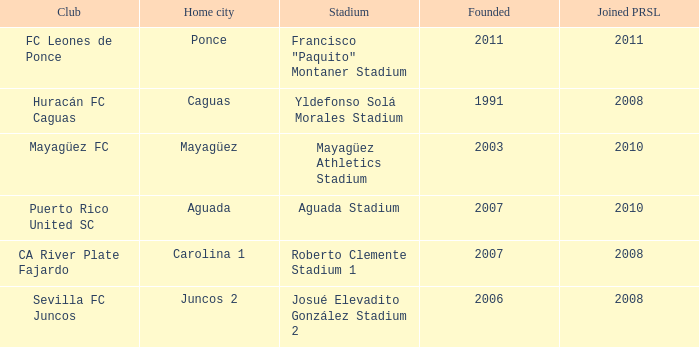When is the latest to join prsl when founded in 2007 and the stadium is roberto clemente stadium 1? 2008.0. 